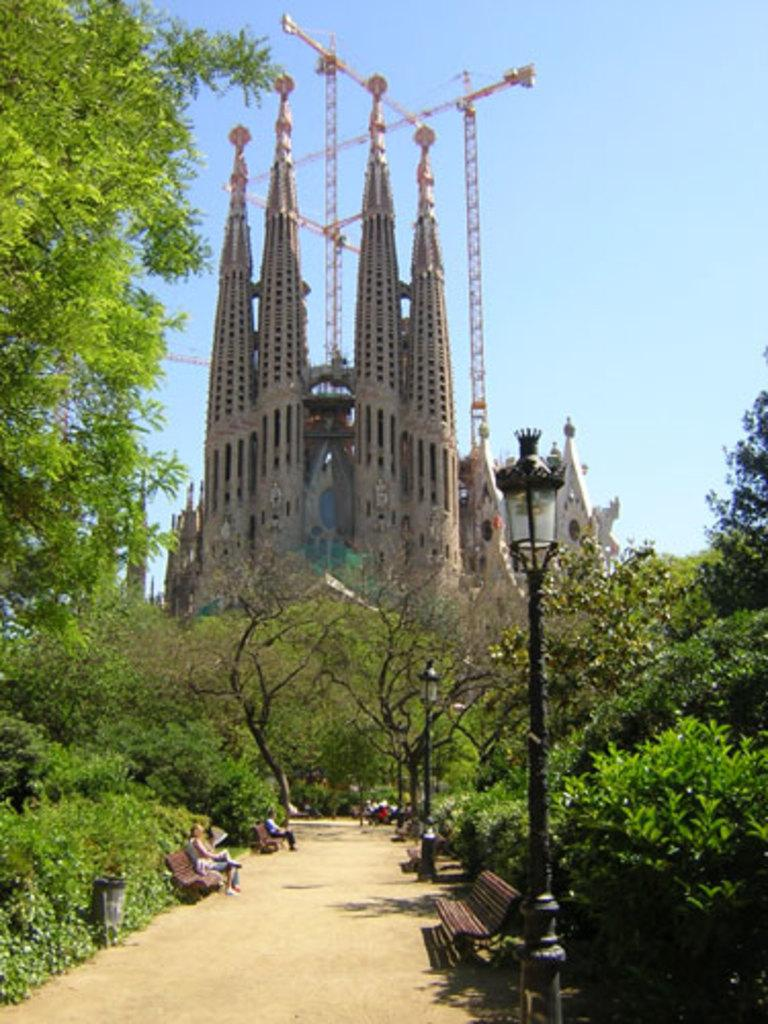What type of seating is visible in the image? There are benches in the image. What are people doing on the benches? People are sitting on the benches. What other objects can be seen in the image? There are poles in the image. What type of vegetation is present in the image? Trees are present in the image. What type of structures can be seen in the image? There are buildings in the image. What is visible in the background of the image? The sky is visible in the background of the image. What type of lettuce is growing on the poles in the image? There is no lettuce present in the image; the poles are not associated with any vegetation. What type of journey are the people on the benches taking in the image? There is no indication of a journey in the image; people are simply sitting on the benches. 